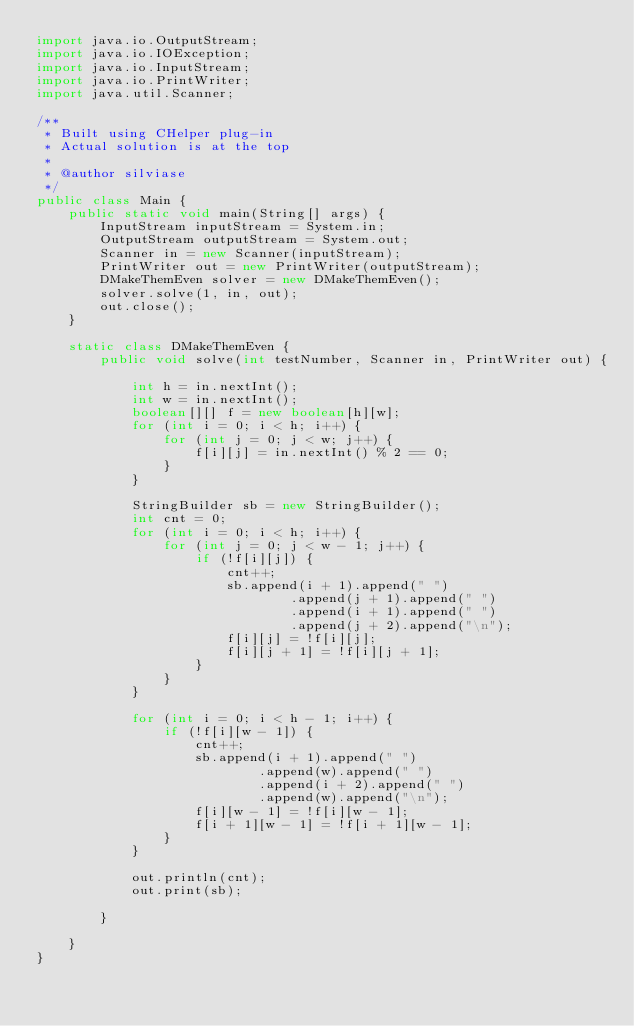<code> <loc_0><loc_0><loc_500><loc_500><_Java_>import java.io.OutputStream;
import java.io.IOException;
import java.io.InputStream;
import java.io.PrintWriter;
import java.util.Scanner;

/**
 * Built using CHelper plug-in
 * Actual solution is at the top
 *
 * @author silviase
 */
public class Main {
    public static void main(String[] args) {
        InputStream inputStream = System.in;
        OutputStream outputStream = System.out;
        Scanner in = new Scanner(inputStream);
        PrintWriter out = new PrintWriter(outputStream);
        DMakeThemEven solver = new DMakeThemEven();
        solver.solve(1, in, out);
        out.close();
    }

    static class DMakeThemEven {
        public void solve(int testNumber, Scanner in, PrintWriter out) {

            int h = in.nextInt();
            int w = in.nextInt();
            boolean[][] f = new boolean[h][w];
            for (int i = 0; i < h; i++) {
                for (int j = 0; j < w; j++) {
                    f[i][j] = in.nextInt() % 2 == 0;
                }
            }

            StringBuilder sb = new StringBuilder();
            int cnt = 0;
            for (int i = 0; i < h; i++) {
                for (int j = 0; j < w - 1; j++) {
                    if (!f[i][j]) {
                        cnt++;
                        sb.append(i + 1).append(" ")
                                .append(j + 1).append(" ")
                                .append(i + 1).append(" ")
                                .append(j + 2).append("\n");
                        f[i][j] = !f[i][j];
                        f[i][j + 1] = !f[i][j + 1];
                    }
                }
            }

            for (int i = 0; i < h - 1; i++) {
                if (!f[i][w - 1]) {
                    cnt++;
                    sb.append(i + 1).append(" ")
                            .append(w).append(" ")
                            .append(i + 2).append(" ")
                            .append(w).append("\n");
                    f[i][w - 1] = !f[i][w - 1];
                    f[i + 1][w - 1] = !f[i + 1][w - 1];
                }
            }

            out.println(cnt);
            out.print(sb);

        }

    }
}

</code> 